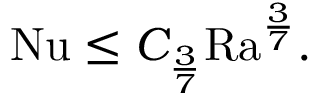<formula> <loc_0><loc_0><loc_500><loc_500>\begin{array} { r } { { N u } \leq C _ { \frac { 3 } { 7 } } { R a } ^ { \frac { 3 } { 7 } } . } \end{array}</formula> 